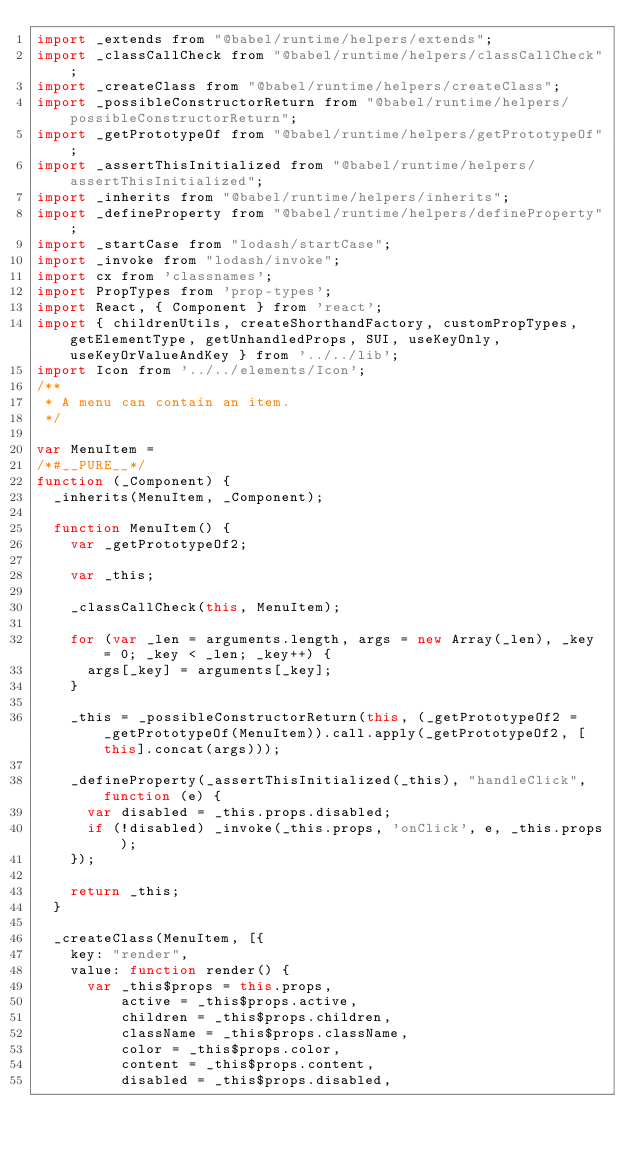Convert code to text. <code><loc_0><loc_0><loc_500><loc_500><_JavaScript_>import _extends from "@babel/runtime/helpers/extends";
import _classCallCheck from "@babel/runtime/helpers/classCallCheck";
import _createClass from "@babel/runtime/helpers/createClass";
import _possibleConstructorReturn from "@babel/runtime/helpers/possibleConstructorReturn";
import _getPrototypeOf from "@babel/runtime/helpers/getPrototypeOf";
import _assertThisInitialized from "@babel/runtime/helpers/assertThisInitialized";
import _inherits from "@babel/runtime/helpers/inherits";
import _defineProperty from "@babel/runtime/helpers/defineProperty";
import _startCase from "lodash/startCase";
import _invoke from "lodash/invoke";
import cx from 'classnames';
import PropTypes from 'prop-types';
import React, { Component } from 'react';
import { childrenUtils, createShorthandFactory, customPropTypes, getElementType, getUnhandledProps, SUI, useKeyOnly, useKeyOrValueAndKey } from '../../lib';
import Icon from '../../elements/Icon';
/**
 * A menu can contain an item.
 */

var MenuItem =
/*#__PURE__*/
function (_Component) {
  _inherits(MenuItem, _Component);

  function MenuItem() {
    var _getPrototypeOf2;

    var _this;

    _classCallCheck(this, MenuItem);

    for (var _len = arguments.length, args = new Array(_len), _key = 0; _key < _len; _key++) {
      args[_key] = arguments[_key];
    }

    _this = _possibleConstructorReturn(this, (_getPrototypeOf2 = _getPrototypeOf(MenuItem)).call.apply(_getPrototypeOf2, [this].concat(args)));

    _defineProperty(_assertThisInitialized(_this), "handleClick", function (e) {
      var disabled = _this.props.disabled;
      if (!disabled) _invoke(_this.props, 'onClick', e, _this.props);
    });

    return _this;
  }

  _createClass(MenuItem, [{
    key: "render",
    value: function render() {
      var _this$props = this.props,
          active = _this$props.active,
          children = _this$props.children,
          className = _this$props.className,
          color = _this$props.color,
          content = _this$props.content,
          disabled = _this$props.disabled,</code> 